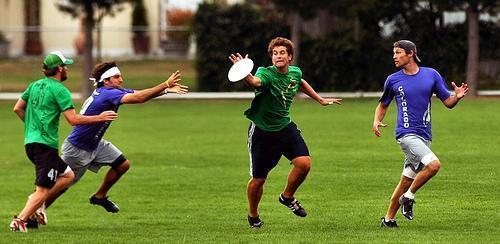How many people have blue shirt on?
Give a very brief answer. 2. How many people are playing?
Give a very brief answer. 4. 